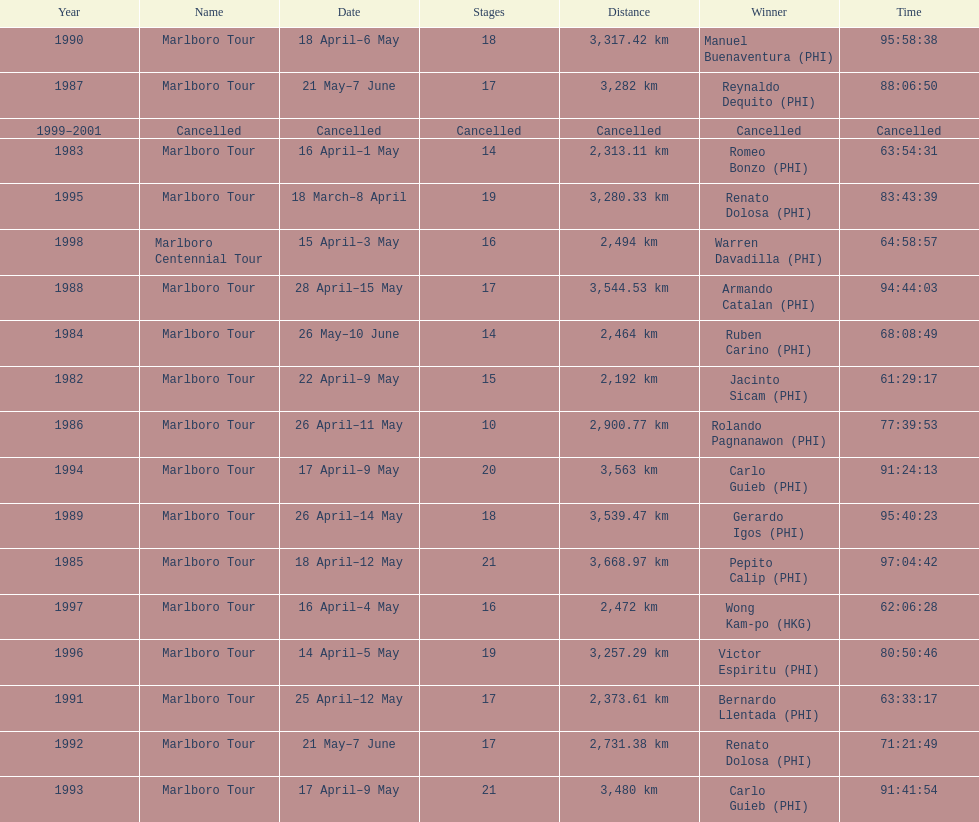How many stages was the 1982 marlboro tour? 15. 